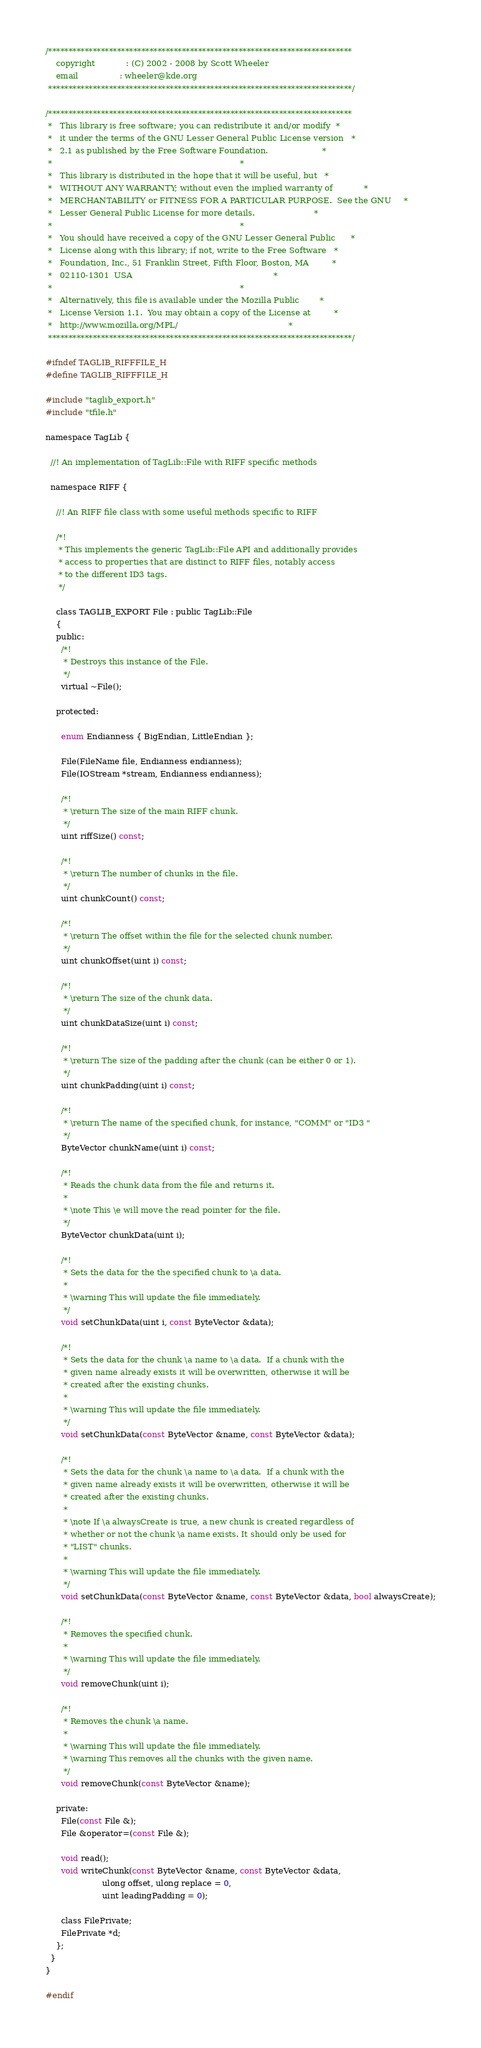<code> <loc_0><loc_0><loc_500><loc_500><_C_>/***************************************************************************
    copyright            : (C) 2002 - 2008 by Scott Wheeler
    email                : wheeler@kde.org
 ***************************************************************************/

/***************************************************************************
 *   This library is free software; you can redistribute it and/or modify  *
 *   it under the terms of the GNU Lesser General Public License version   *
 *   2.1 as published by the Free Software Foundation.                     *
 *                                                                         *
 *   This library is distributed in the hope that it will be useful, but   *
 *   WITHOUT ANY WARRANTY; without even the implied warranty of            *
 *   MERCHANTABILITY or FITNESS FOR A PARTICULAR PURPOSE.  See the GNU     *
 *   Lesser General Public License for more details.                       *
 *                                                                         *
 *   You should have received a copy of the GNU Lesser General Public      *
 *   License along with this library; if not, write to the Free Software   *
 *   Foundation, Inc., 51 Franklin Street, Fifth Floor, Boston, MA         *
 *   02110-1301  USA                                                       *
 *                                                                         *
 *   Alternatively, this file is available under the Mozilla Public        *
 *   License Version 1.1.  You may obtain a copy of the License at         *
 *   http://www.mozilla.org/MPL/                                           *
 ***************************************************************************/

#ifndef TAGLIB_RIFFFILE_H
#define TAGLIB_RIFFFILE_H

#include "taglib_export.h"
#include "tfile.h"

namespace TagLib {

  //! An implementation of TagLib::File with RIFF specific methods

  namespace RIFF {

    //! An RIFF file class with some useful methods specific to RIFF

    /*!
     * This implements the generic TagLib::File API and additionally provides
     * access to properties that are distinct to RIFF files, notably access
     * to the different ID3 tags.
     */

    class TAGLIB_EXPORT File : public TagLib::File
    {
    public:
      /*!
       * Destroys this instance of the File.
       */
      virtual ~File();

    protected:

      enum Endianness { BigEndian, LittleEndian };

      File(FileName file, Endianness endianness);
      File(IOStream *stream, Endianness endianness);

      /*!
       * \return The size of the main RIFF chunk.
       */
      uint riffSize() const;

      /*!
       * \return The number of chunks in the file.
       */
      uint chunkCount() const;

      /*!
       * \return The offset within the file for the selected chunk number.
       */
      uint chunkOffset(uint i) const;

      /*!
       * \return The size of the chunk data.
       */
      uint chunkDataSize(uint i) const;

      /*!
       * \return The size of the padding after the chunk (can be either 0 or 1).
       */
      uint chunkPadding(uint i) const;

      /*!
       * \return The name of the specified chunk, for instance, "COMM" or "ID3 "
       */
      ByteVector chunkName(uint i) const;

      /*!
       * Reads the chunk data from the file and returns it.
       *
       * \note This \e will move the read pointer for the file.
       */
      ByteVector chunkData(uint i);

      /*!
       * Sets the data for the the specified chunk to \a data. 
       *
       * \warning This will update the file immediately.
       */
      void setChunkData(uint i, const ByteVector &data);

      /*!
       * Sets the data for the chunk \a name to \a data.  If a chunk with the
       * given name already exists it will be overwritten, otherwise it will be
       * created after the existing chunks.
       *
       * \warning This will update the file immediately.
       */
      void setChunkData(const ByteVector &name, const ByteVector &data);

      /*!
       * Sets the data for the chunk \a name to \a data.  If a chunk with the
       * given name already exists it will be overwritten, otherwise it will be
       * created after the existing chunks.
       *
       * \note If \a alwaysCreate is true, a new chunk is created regardless of 
       * whether or not the chunk \a name exists. It should only be used for 
       * "LIST" chunks. 
       *
       * \warning This will update the file immediately.
       */
      void setChunkData(const ByteVector &name, const ByteVector &data, bool alwaysCreate);

      /*!
       * Removes the specified chunk.
       *
       * \warning This will update the file immediately.
       */
      void removeChunk(uint i);

      /*!
       * Removes the chunk \a name.
       *
       * \warning This will update the file immediately.
       * \warning This removes all the chunks with the given name.
       */
      void removeChunk(const ByteVector &name);

    private:
      File(const File &);
      File &operator=(const File &);

      void read();
      void writeChunk(const ByteVector &name, const ByteVector &data,
                      ulong offset, ulong replace = 0,
                      uint leadingPadding = 0);

      class FilePrivate;
      FilePrivate *d;
    };
  }
}

#endif
</code> 